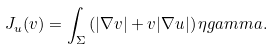Convert formula to latex. <formula><loc_0><loc_0><loc_500><loc_500>J _ { u } ( v ) = \int _ { \Sigma } \left ( | { \nabla } v | + v | { \nabla } u | \right ) \eta g a m m a .</formula> 